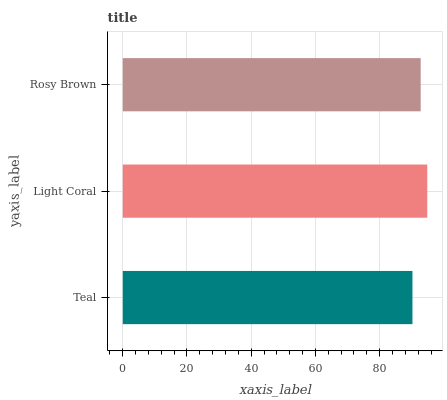Is Teal the minimum?
Answer yes or no. Yes. Is Light Coral the maximum?
Answer yes or no. Yes. Is Rosy Brown the minimum?
Answer yes or no. No. Is Rosy Brown the maximum?
Answer yes or no. No. Is Light Coral greater than Rosy Brown?
Answer yes or no. Yes. Is Rosy Brown less than Light Coral?
Answer yes or no. Yes. Is Rosy Brown greater than Light Coral?
Answer yes or no. No. Is Light Coral less than Rosy Brown?
Answer yes or no. No. Is Rosy Brown the high median?
Answer yes or no. Yes. Is Rosy Brown the low median?
Answer yes or no. Yes. Is Teal the high median?
Answer yes or no. No. Is Teal the low median?
Answer yes or no. No. 